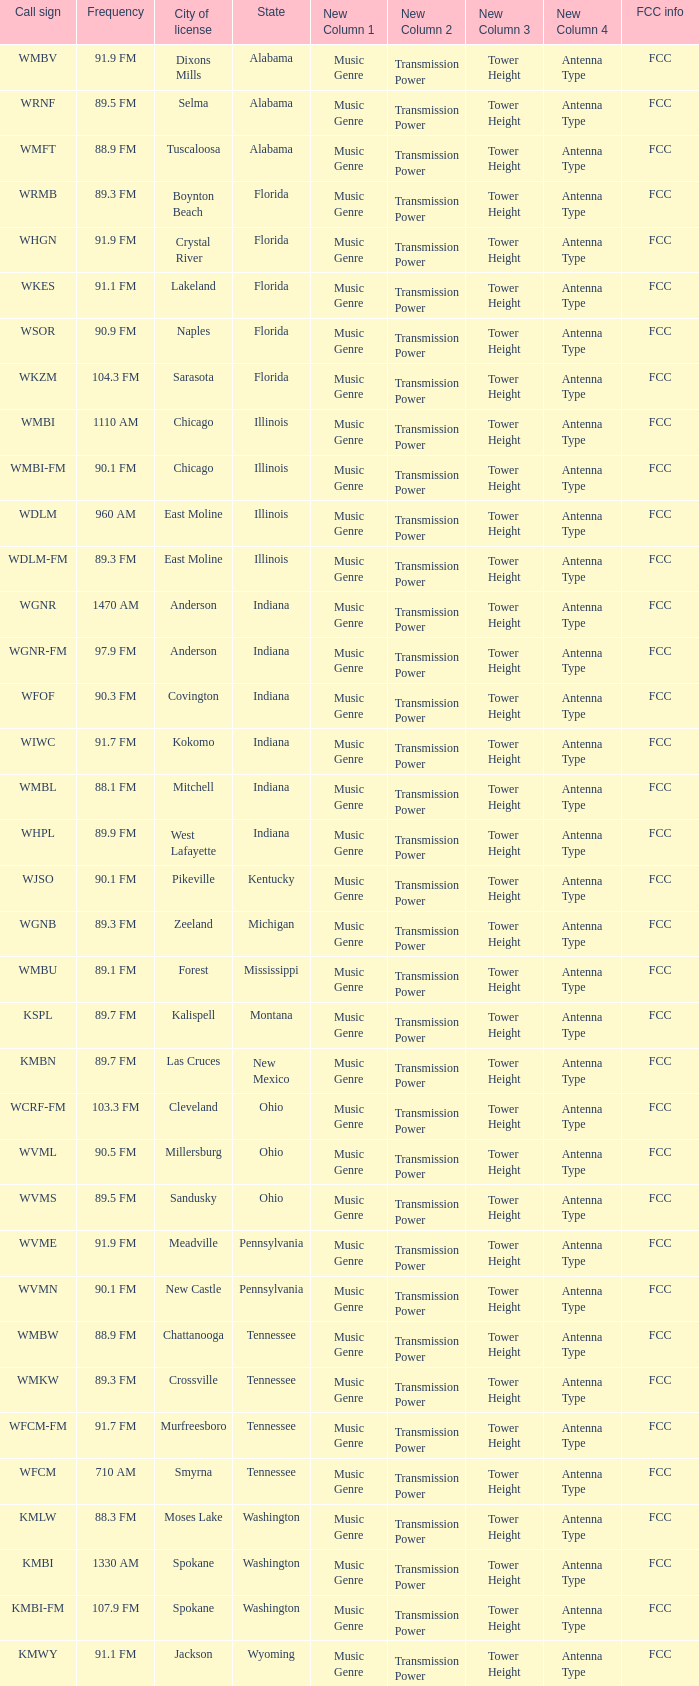What is the frequency of the radio station in Indiana that has a call sign of WGNR? 1470 AM. 